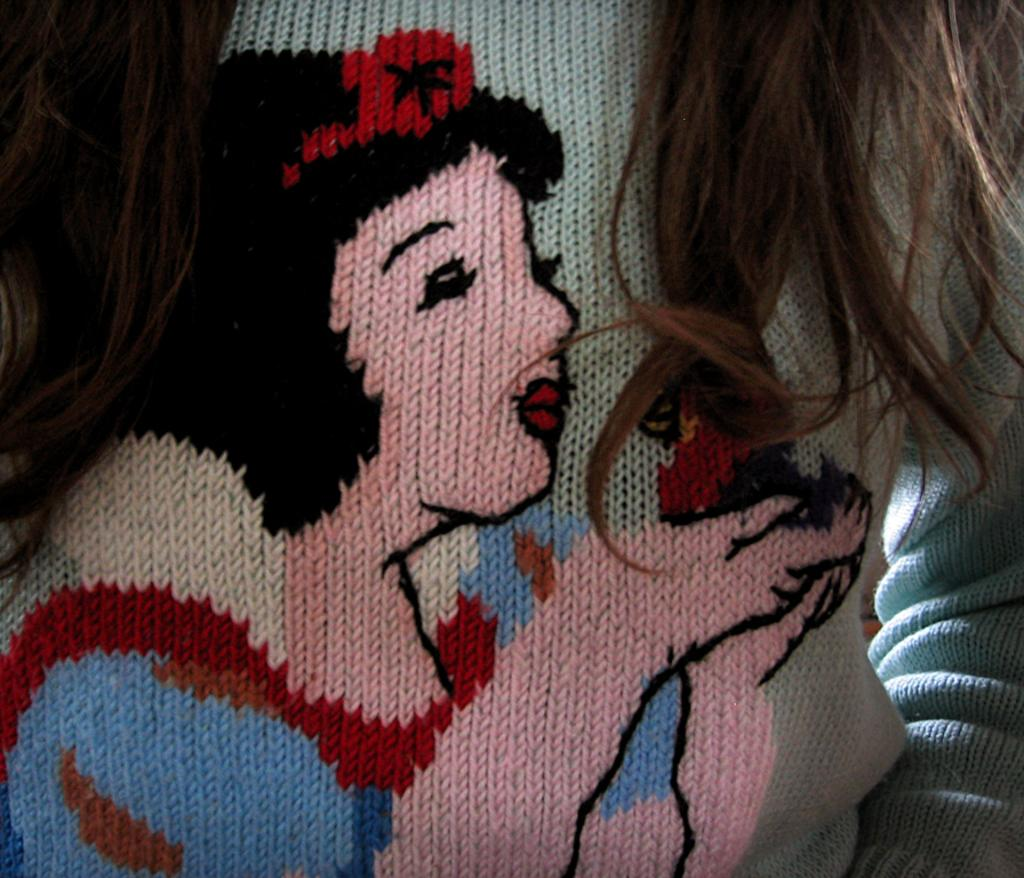What is depicted on the cloth on the left side of the image? There is a painting of a person on a cloth on the left side of the image. What can be seen on the right side of the image? There is a person's hair on the right side of the image. What is the material that the hair and the painting are on? There is a cloth in the image. What type of pear is hanging from the wire in the image? There is no pear or wire present in the image. How does the person in the painting show respect to others? The image does not provide information about the person's actions or intentions, so it cannot be determined how they show respect to others. 